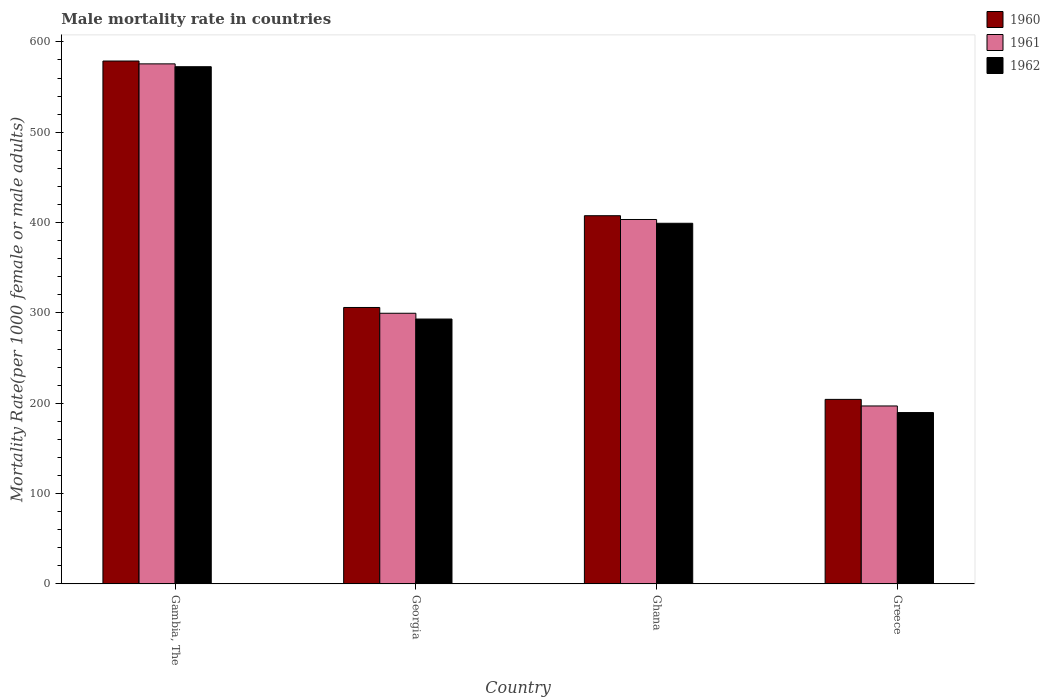Are the number of bars per tick equal to the number of legend labels?
Give a very brief answer. Yes. How many bars are there on the 2nd tick from the right?
Your answer should be very brief. 3. What is the label of the 1st group of bars from the left?
Your response must be concise. Gambia, The. In how many cases, is the number of bars for a given country not equal to the number of legend labels?
Your answer should be compact. 0. What is the male mortality rate in 1961 in Greece?
Provide a succinct answer. 196.94. Across all countries, what is the maximum male mortality rate in 1960?
Your answer should be compact. 578.82. Across all countries, what is the minimum male mortality rate in 1960?
Your answer should be compact. 204.23. In which country was the male mortality rate in 1961 maximum?
Provide a succinct answer. Gambia, The. In which country was the male mortality rate in 1961 minimum?
Ensure brevity in your answer.  Greece. What is the total male mortality rate in 1962 in the graph?
Your answer should be very brief. 1454.54. What is the difference between the male mortality rate in 1960 in Gambia, The and that in Georgia?
Your answer should be very brief. 272.84. What is the difference between the male mortality rate in 1962 in Georgia and the male mortality rate in 1961 in Ghana?
Your answer should be compact. -110.2. What is the average male mortality rate in 1962 per country?
Your answer should be very brief. 363.63. What is the difference between the male mortality rate of/in 1960 and male mortality rate of/in 1961 in Greece?
Ensure brevity in your answer.  7.29. In how many countries, is the male mortality rate in 1960 greater than 40?
Your answer should be compact. 4. What is the ratio of the male mortality rate in 1961 in Gambia, The to that in Ghana?
Keep it short and to the point. 1.43. Is the male mortality rate in 1960 in Georgia less than that in Ghana?
Provide a short and direct response. Yes. Is the difference between the male mortality rate in 1960 in Georgia and Ghana greater than the difference between the male mortality rate in 1961 in Georgia and Ghana?
Give a very brief answer. Yes. What is the difference between the highest and the second highest male mortality rate in 1962?
Keep it short and to the point. 279.34. What is the difference between the highest and the lowest male mortality rate in 1961?
Provide a short and direct response. 378.73. In how many countries, is the male mortality rate in 1962 greater than the average male mortality rate in 1962 taken over all countries?
Your answer should be compact. 2. Is the sum of the male mortality rate in 1961 in Ghana and Greece greater than the maximum male mortality rate in 1962 across all countries?
Keep it short and to the point. Yes. What does the 2nd bar from the right in Greece represents?
Give a very brief answer. 1961. Are all the bars in the graph horizontal?
Offer a very short reply. No. How many countries are there in the graph?
Offer a terse response. 4. What is the difference between two consecutive major ticks on the Y-axis?
Your answer should be compact. 100. Does the graph contain any zero values?
Make the answer very short. No. Where does the legend appear in the graph?
Offer a very short reply. Top right. What is the title of the graph?
Give a very brief answer. Male mortality rate in countries. What is the label or title of the Y-axis?
Offer a very short reply. Mortality Rate(per 1000 female or male adults). What is the Mortality Rate(per 1000 female or male adults) of 1960 in Gambia, The?
Your answer should be compact. 578.82. What is the Mortality Rate(per 1000 female or male adults) of 1961 in Gambia, The?
Provide a succinct answer. 575.67. What is the Mortality Rate(per 1000 female or male adults) of 1962 in Gambia, The?
Your answer should be very brief. 572.52. What is the Mortality Rate(per 1000 female or male adults) of 1960 in Georgia?
Your answer should be very brief. 305.98. What is the Mortality Rate(per 1000 female or male adults) of 1961 in Georgia?
Your answer should be compact. 299.58. What is the Mortality Rate(per 1000 female or male adults) in 1962 in Georgia?
Make the answer very short. 293.18. What is the Mortality Rate(per 1000 female or male adults) of 1960 in Ghana?
Ensure brevity in your answer.  407.57. What is the Mortality Rate(per 1000 female or male adults) in 1961 in Ghana?
Your answer should be compact. 403.38. What is the Mortality Rate(per 1000 female or male adults) in 1962 in Ghana?
Offer a terse response. 399.19. What is the Mortality Rate(per 1000 female or male adults) of 1960 in Greece?
Provide a succinct answer. 204.23. What is the Mortality Rate(per 1000 female or male adults) of 1961 in Greece?
Offer a very short reply. 196.94. What is the Mortality Rate(per 1000 female or male adults) in 1962 in Greece?
Ensure brevity in your answer.  189.65. Across all countries, what is the maximum Mortality Rate(per 1000 female or male adults) in 1960?
Your response must be concise. 578.82. Across all countries, what is the maximum Mortality Rate(per 1000 female or male adults) of 1961?
Your answer should be compact. 575.67. Across all countries, what is the maximum Mortality Rate(per 1000 female or male adults) of 1962?
Make the answer very short. 572.52. Across all countries, what is the minimum Mortality Rate(per 1000 female or male adults) of 1960?
Ensure brevity in your answer.  204.23. Across all countries, what is the minimum Mortality Rate(per 1000 female or male adults) in 1961?
Offer a terse response. 196.94. Across all countries, what is the minimum Mortality Rate(per 1000 female or male adults) of 1962?
Your answer should be compact. 189.65. What is the total Mortality Rate(per 1000 female or male adults) of 1960 in the graph?
Provide a succinct answer. 1496.6. What is the total Mortality Rate(per 1000 female or male adults) in 1961 in the graph?
Ensure brevity in your answer.  1475.57. What is the total Mortality Rate(per 1000 female or male adults) in 1962 in the graph?
Keep it short and to the point. 1454.54. What is the difference between the Mortality Rate(per 1000 female or male adults) in 1960 in Gambia, The and that in Georgia?
Keep it short and to the point. 272.84. What is the difference between the Mortality Rate(per 1000 female or male adults) in 1961 in Gambia, The and that in Georgia?
Ensure brevity in your answer.  276.09. What is the difference between the Mortality Rate(per 1000 female or male adults) in 1962 in Gambia, The and that in Georgia?
Provide a succinct answer. 279.34. What is the difference between the Mortality Rate(per 1000 female or male adults) in 1960 in Gambia, The and that in Ghana?
Your response must be concise. 171.25. What is the difference between the Mortality Rate(per 1000 female or male adults) of 1961 in Gambia, The and that in Ghana?
Provide a succinct answer. 172.29. What is the difference between the Mortality Rate(per 1000 female or male adults) in 1962 in Gambia, The and that in Ghana?
Make the answer very short. 173.33. What is the difference between the Mortality Rate(per 1000 female or male adults) in 1960 in Gambia, The and that in Greece?
Provide a short and direct response. 374.59. What is the difference between the Mortality Rate(per 1000 female or male adults) of 1961 in Gambia, The and that in Greece?
Keep it short and to the point. 378.73. What is the difference between the Mortality Rate(per 1000 female or male adults) of 1962 in Gambia, The and that in Greece?
Give a very brief answer. 382.87. What is the difference between the Mortality Rate(per 1000 female or male adults) in 1960 in Georgia and that in Ghana?
Your answer should be very brief. -101.59. What is the difference between the Mortality Rate(per 1000 female or male adults) of 1961 in Georgia and that in Ghana?
Your answer should be very brief. -103.8. What is the difference between the Mortality Rate(per 1000 female or male adults) in 1962 in Georgia and that in Ghana?
Your response must be concise. -106.02. What is the difference between the Mortality Rate(per 1000 female or male adults) in 1960 in Georgia and that in Greece?
Keep it short and to the point. 101.75. What is the difference between the Mortality Rate(per 1000 female or male adults) of 1961 in Georgia and that in Greece?
Provide a succinct answer. 102.64. What is the difference between the Mortality Rate(per 1000 female or male adults) of 1962 in Georgia and that in Greece?
Provide a succinct answer. 103.53. What is the difference between the Mortality Rate(per 1000 female or male adults) of 1960 in Ghana and that in Greece?
Provide a short and direct response. 203.34. What is the difference between the Mortality Rate(per 1000 female or male adults) of 1961 in Ghana and that in Greece?
Keep it short and to the point. 206.44. What is the difference between the Mortality Rate(per 1000 female or male adults) in 1962 in Ghana and that in Greece?
Offer a very short reply. 209.55. What is the difference between the Mortality Rate(per 1000 female or male adults) in 1960 in Gambia, The and the Mortality Rate(per 1000 female or male adults) in 1961 in Georgia?
Your answer should be compact. 279.24. What is the difference between the Mortality Rate(per 1000 female or male adults) of 1960 in Gambia, The and the Mortality Rate(per 1000 female or male adults) of 1962 in Georgia?
Offer a very short reply. 285.64. What is the difference between the Mortality Rate(per 1000 female or male adults) in 1961 in Gambia, The and the Mortality Rate(per 1000 female or male adults) in 1962 in Georgia?
Offer a very short reply. 282.49. What is the difference between the Mortality Rate(per 1000 female or male adults) in 1960 in Gambia, The and the Mortality Rate(per 1000 female or male adults) in 1961 in Ghana?
Your response must be concise. 175.44. What is the difference between the Mortality Rate(per 1000 female or male adults) of 1960 in Gambia, The and the Mortality Rate(per 1000 female or male adults) of 1962 in Ghana?
Offer a very short reply. 179.63. What is the difference between the Mortality Rate(per 1000 female or male adults) of 1961 in Gambia, The and the Mortality Rate(per 1000 female or male adults) of 1962 in Ghana?
Ensure brevity in your answer.  176.48. What is the difference between the Mortality Rate(per 1000 female or male adults) of 1960 in Gambia, The and the Mortality Rate(per 1000 female or male adults) of 1961 in Greece?
Offer a terse response. 381.88. What is the difference between the Mortality Rate(per 1000 female or male adults) of 1960 in Gambia, The and the Mortality Rate(per 1000 female or male adults) of 1962 in Greece?
Ensure brevity in your answer.  389.17. What is the difference between the Mortality Rate(per 1000 female or male adults) of 1961 in Gambia, The and the Mortality Rate(per 1000 female or male adults) of 1962 in Greece?
Your answer should be compact. 386.02. What is the difference between the Mortality Rate(per 1000 female or male adults) in 1960 in Georgia and the Mortality Rate(per 1000 female or male adults) in 1961 in Ghana?
Provide a succinct answer. -97.4. What is the difference between the Mortality Rate(per 1000 female or male adults) in 1960 in Georgia and the Mortality Rate(per 1000 female or male adults) in 1962 in Ghana?
Keep it short and to the point. -93.22. What is the difference between the Mortality Rate(per 1000 female or male adults) of 1961 in Georgia and the Mortality Rate(per 1000 female or male adults) of 1962 in Ghana?
Provide a short and direct response. -99.61. What is the difference between the Mortality Rate(per 1000 female or male adults) in 1960 in Georgia and the Mortality Rate(per 1000 female or male adults) in 1961 in Greece?
Your response must be concise. 109.04. What is the difference between the Mortality Rate(per 1000 female or male adults) of 1960 in Georgia and the Mortality Rate(per 1000 female or male adults) of 1962 in Greece?
Provide a short and direct response. 116.33. What is the difference between the Mortality Rate(per 1000 female or male adults) of 1961 in Georgia and the Mortality Rate(per 1000 female or male adults) of 1962 in Greece?
Provide a short and direct response. 109.93. What is the difference between the Mortality Rate(per 1000 female or male adults) of 1960 in Ghana and the Mortality Rate(per 1000 female or male adults) of 1961 in Greece?
Your answer should be very brief. 210.63. What is the difference between the Mortality Rate(per 1000 female or male adults) of 1960 in Ghana and the Mortality Rate(per 1000 female or male adults) of 1962 in Greece?
Provide a succinct answer. 217.92. What is the difference between the Mortality Rate(per 1000 female or male adults) of 1961 in Ghana and the Mortality Rate(per 1000 female or male adults) of 1962 in Greece?
Give a very brief answer. 213.73. What is the average Mortality Rate(per 1000 female or male adults) of 1960 per country?
Make the answer very short. 374.15. What is the average Mortality Rate(per 1000 female or male adults) in 1961 per country?
Your answer should be compact. 368.89. What is the average Mortality Rate(per 1000 female or male adults) in 1962 per country?
Offer a very short reply. 363.63. What is the difference between the Mortality Rate(per 1000 female or male adults) of 1960 and Mortality Rate(per 1000 female or male adults) of 1961 in Gambia, The?
Give a very brief answer. 3.15. What is the difference between the Mortality Rate(per 1000 female or male adults) in 1960 and Mortality Rate(per 1000 female or male adults) in 1962 in Gambia, The?
Your answer should be compact. 6.3. What is the difference between the Mortality Rate(per 1000 female or male adults) in 1961 and Mortality Rate(per 1000 female or male adults) in 1962 in Gambia, The?
Provide a succinct answer. 3.15. What is the difference between the Mortality Rate(per 1000 female or male adults) of 1960 and Mortality Rate(per 1000 female or male adults) of 1961 in Georgia?
Make the answer very short. 6.4. What is the difference between the Mortality Rate(per 1000 female or male adults) of 1960 and Mortality Rate(per 1000 female or male adults) of 1961 in Ghana?
Your answer should be compact. 4.19. What is the difference between the Mortality Rate(per 1000 female or male adults) in 1960 and Mortality Rate(per 1000 female or male adults) in 1962 in Ghana?
Offer a terse response. 8.38. What is the difference between the Mortality Rate(per 1000 female or male adults) of 1961 and Mortality Rate(per 1000 female or male adults) of 1962 in Ghana?
Offer a very short reply. 4.19. What is the difference between the Mortality Rate(per 1000 female or male adults) of 1960 and Mortality Rate(per 1000 female or male adults) of 1961 in Greece?
Offer a terse response. 7.29. What is the difference between the Mortality Rate(per 1000 female or male adults) of 1960 and Mortality Rate(per 1000 female or male adults) of 1962 in Greece?
Your response must be concise. 14.58. What is the difference between the Mortality Rate(per 1000 female or male adults) in 1961 and Mortality Rate(per 1000 female or male adults) in 1962 in Greece?
Provide a short and direct response. 7.29. What is the ratio of the Mortality Rate(per 1000 female or male adults) of 1960 in Gambia, The to that in Georgia?
Provide a short and direct response. 1.89. What is the ratio of the Mortality Rate(per 1000 female or male adults) in 1961 in Gambia, The to that in Georgia?
Offer a very short reply. 1.92. What is the ratio of the Mortality Rate(per 1000 female or male adults) of 1962 in Gambia, The to that in Georgia?
Keep it short and to the point. 1.95. What is the ratio of the Mortality Rate(per 1000 female or male adults) of 1960 in Gambia, The to that in Ghana?
Provide a succinct answer. 1.42. What is the ratio of the Mortality Rate(per 1000 female or male adults) in 1961 in Gambia, The to that in Ghana?
Your response must be concise. 1.43. What is the ratio of the Mortality Rate(per 1000 female or male adults) of 1962 in Gambia, The to that in Ghana?
Make the answer very short. 1.43. What is the ratio of the Mortality Rate(per 1000 female or male adults) in 1960 in Gambia, The to that in Greece?
Provide a short and direct response. 2.83. What is the ratio of the Mortality Rate(per 1000 female or male adults) in 1961 in Gambia, The to that in Greece?
Give a very brief answer. 2.92. What is the ratio of the Mortality Rate(per 1000 female or male adults) in 1962 in Gambia, The to that in Greece?
Your answer should be compact. 3.02. What is the ratio of the Mortality Rate(per 1000 female or male adults) of 1960 in Georgia to that in Ghana?
Your response must be concise. 0.75. What is the ratio of the Mortality Rate(per 1000 female or male adults) in 1961 in Georgia to that in Ghana?
Provide a succinct answer. 0.74. What is the ratio of the Mortality Rate(per 1000 female or male adults) of 1962 in Georgia to that in Ghana?
Make the answer very short. 0.73. What is the ratio of the Mortality Rate(per 1000 female or male adults) in 1960 in Georgia to that in Greece?
Provide a short and direct response. 1.5. What is the ratio of the Mortality Rate(per 1000 female or male adults) in 1961 in Georgia to that in Greece?
Provide a succinct answer. 1.52. What is the ratio of the Mortality Rate(per 1000 female or male adults) in 1962 in Georgia to that in Greece?
Offer a terse response. 1.55. What is the ratio of the Mortality Rate(per 1000 female or male adults) of 1960 in Ghana to that in Greece?
Your response must be concise. 2. What is the ratio of the Mortality Rate(per 1000 female or male adults) of 1961 in Ghana to that in Greece?
Make the answer very short. 2.05. What is the ratio of the Mortality Rate(per 1000 female or male adults) in 1962 in Ghana to that in Greece?
Give a very brief answer. 2.1. What is the difference between the highest and the second highest Mortality Rate(per 1000 female or male adults) in 1960?
Keep it short and to the point. 171.25. What is the difference between the highest and the second highest Mortality Rate(per 1000 female or male adults) in 1961?
Offer a terse response. 172.29. What is the difference between the highest and the second highest Mortality Rate(per 1000 female or male adults) of 1962?
Keep it short and to the point. 173.33. What is the difference between the highest and the lowest Mortality Rate(per 1000 female or male adults) in 1960?
Keep it short and to the point. 374.59. What is the difference between the highest and the lowest Mortality Rate(per 1000 female or male adults) in 1961?
Offer a terse response. 378.73. What is the difference between the highest and the lowest Mortality Rate(per 1000 female or male adults) of 1962?
Give a very brief answer. 382.87. 